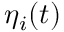Convert formula to latex. <formula><loc_0><loc_0><loc_500><loc_500>\eta _ { i } ( t )</formula> 